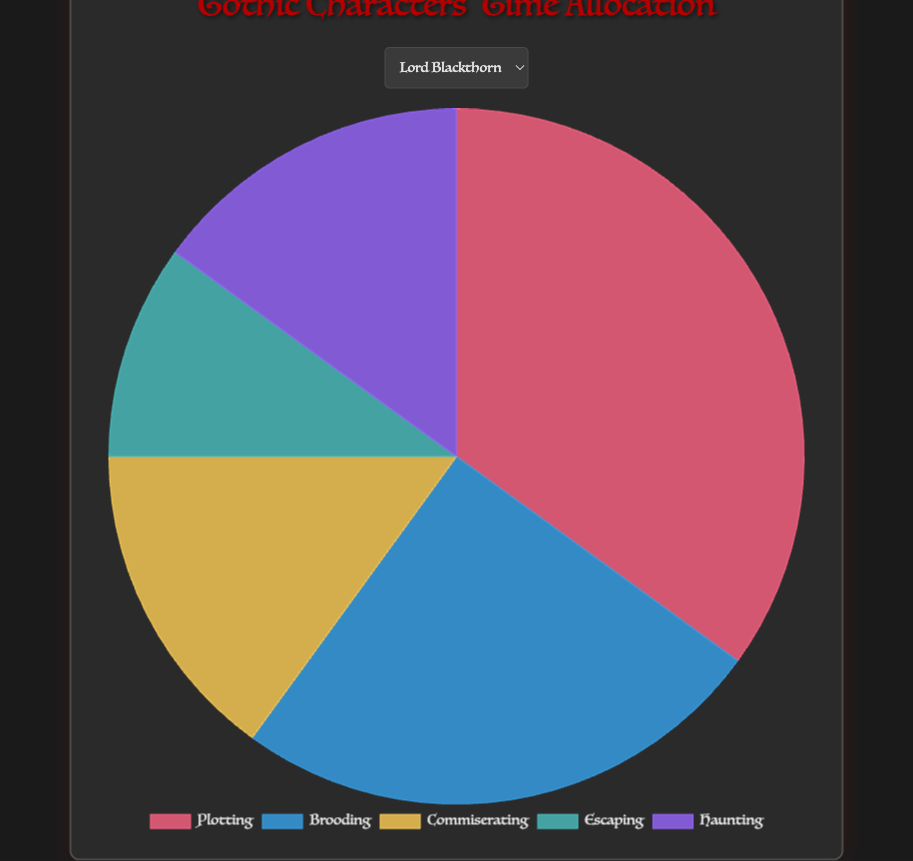Which character spends the most time brooding? By visually checking the pie chart segments for each character, we observe that Vesper Thorn allocates the largest portion to brooding, which is 40%.
Answer: Vesper Thorn What is the combined time spent on Plotting and Haunting for Specter Whisp? Adding the percentages for Plotting (30%) and Haunting (20%) for Specter Whisp results in 30% + 20% = 50%.
Answer: 50% Which character spends an equal amount of time on Escaping and Haunting? By visually comparing the segments across all characters, we find that Shade Walker spends 5% on Escaping and 25% on Haunting, which are not equal. However, no character has equal time for Escaping and Haunting.
Answer: None Who spends the least time on Commiserating? Observing the pie chart, it can be seen that Shade Walker allots only 10% of their time to Commiserating, which is the least among all characters.
Answer: Shade Walker Compare the time spent on Brooding by Lady Revenant and Lord Blackthorn. Lady Revenant spends 30% of her time brooding, while Lord Blackthorn spends 25%. Thus, Lady Revenant spends more time brooding than Lord Blackthorn.
Answer: Lady Revenant What is the average time spent on Escaping across all characters? Adding the times for Escaping across all characters: 10 (Lord Blackthorn) + 5 (Lady Revenant) + 5 (Shade Walker) + 10 (Specter Whisp) + 10 (Vesper Thorn) = 40. Dividing by the number of characters (5), we get 40/5 = 8%.
Answer: 8% Compare the time allocation for Plotting between Vesper Thorn and Specter Whisp. Vesper Thorn spends 20% of their time plotting, while Specter Whisp spends 30%. Therefore, Specter Whisp allocates more time to Plotting.
Answer: Specter Whisp Which character has the most evenly distributed time among the activities? By comparing the visual balance of the pie chart segments, Lady Revenant appears to have a more even distribution of time across all activities.
Answer: Lady Revenant What percentage of time does Lord Blackthorn spend on non-Plotting activities? Subtracting the time spent on Plotting (35%) from the total (100%), we get 100% - 35% = 65%.
Answer: 65% Who has the highest combined total for Commiserating and Brooding? Adding the percentages for Commiserating and Brooding, Vesper Thorn has the highest combined total: 40% (Brooding) + 15% (Commiserating) = 55%.
Answer: Vesper Thorn 